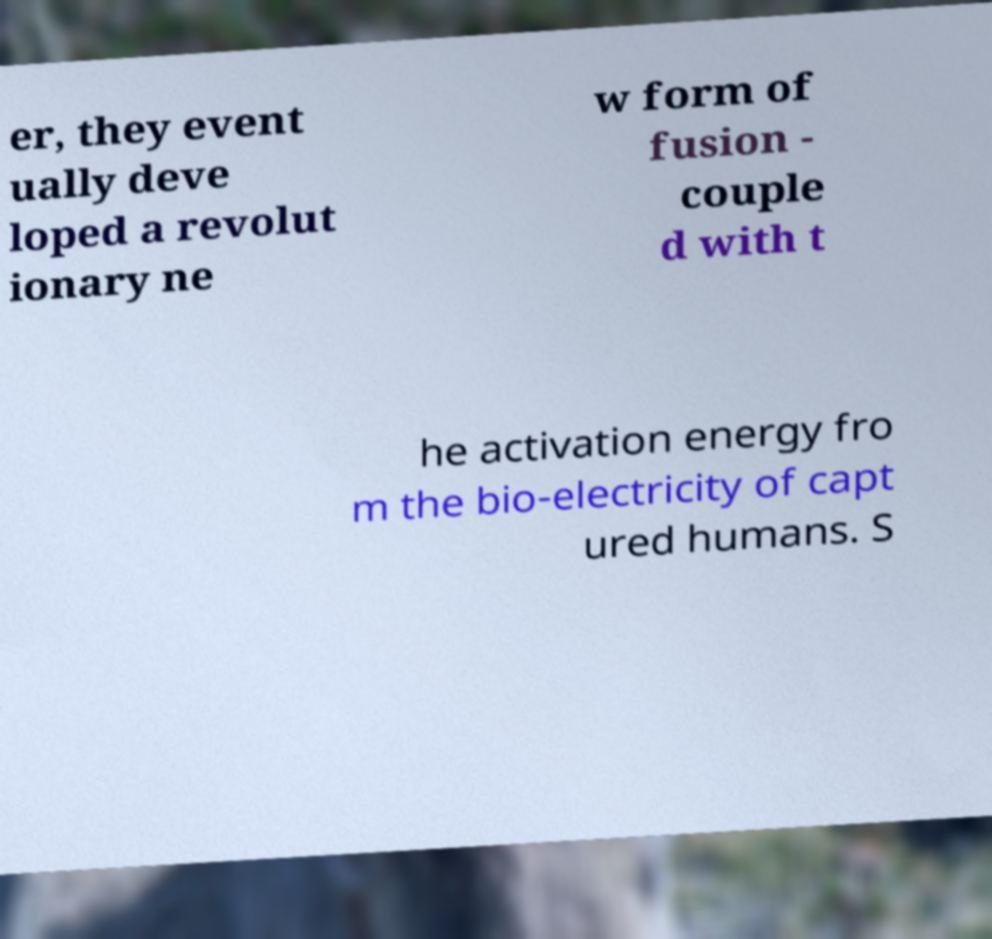What messages or text are displayed in this image? I need them in a readable, typed format. er, they event ually deve loped a revolut ionary ne w form of fusion - couple d with t he activation energy fro m the bio-electricity of capt ured humans. S 